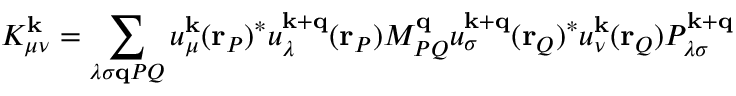<formula> <loc_0><loc_0><loc_500><loc_500>K _ { \mu \nu } ^ { k } = \sum _ { \lambda \sigma q P Q } u _ { \mu } ^ { k } ( r _ { P } ) ^ { * } u _ { \lambda } ^ { k + q } ( r _ { P } ) M _ { P Q } ^ { q } u _ { \sigma } ^ { k + q } ( r _ { Q } ) ^ { * } u _ { \nu } ^ { k } ( r _ { Q } ) P _ { \lambda \sigma } ^ { k + q }</formula> 